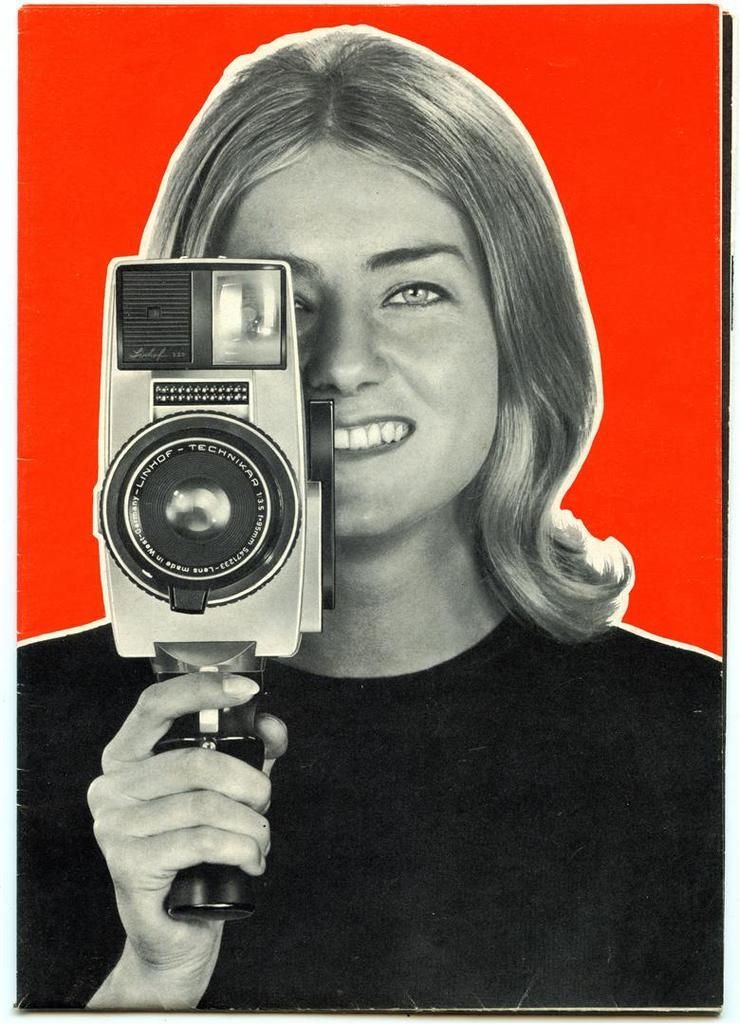What is the main subject of the image? There is a picture of a lady in the image. What is the lady holding in the image? The lady is holding a camera. What can be observed about the background of the image? The background of the image is red. How is the lady's expression in the image? The lady is smiling. How many cherries can be seen in the lady's eye in the image? There are no cherries present in the image, and the lady's eye cannot be observed in the provided facts. 